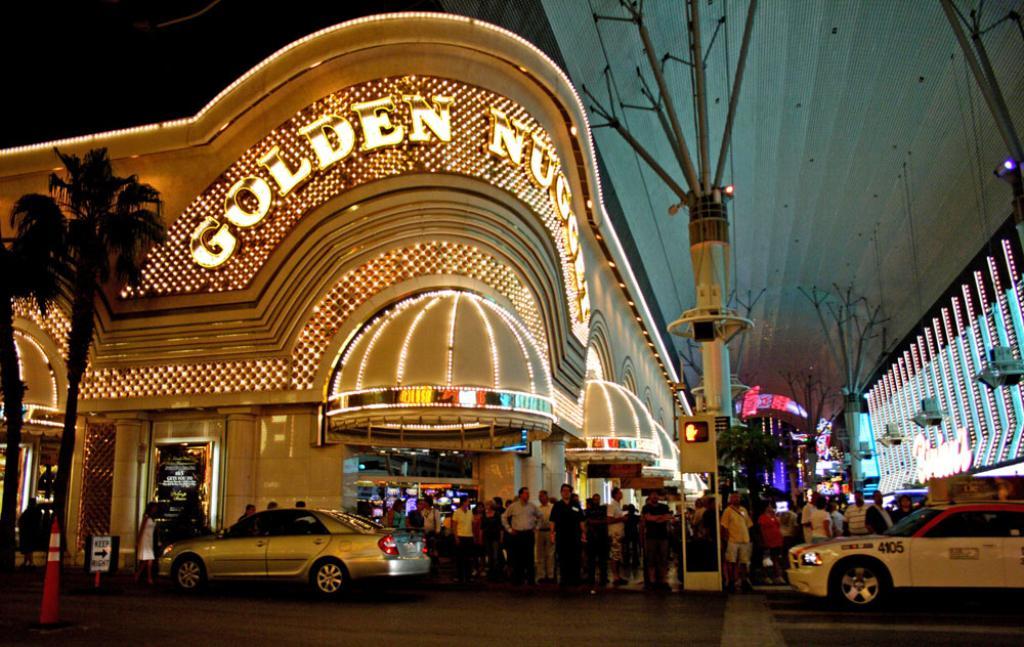What is the name of this casino?
Your response must be concise. Golden nugget. What is the taxi number?
Your answer should be compact. 4105. 